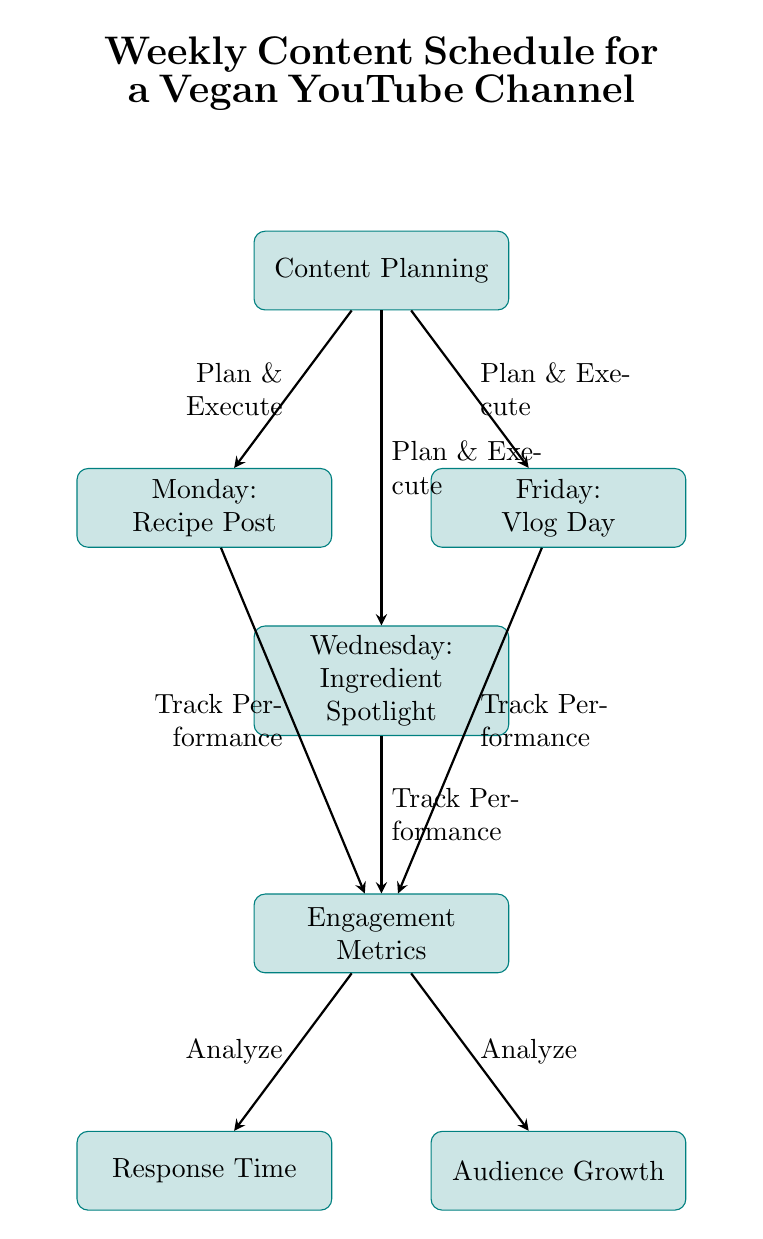What three types of content are scheduled for the week? The diagram lists the three types of content: "Recipe Post" on Monday, "Ingredient Spotlight" on Wednesday, and "Vlog Day" on Friday.
Answer: Recipe Post, Ingredient Spotlight, Vlog Day How many main activities are listed in the diagram? There are three main content activities (Recipe Post, Ingredient Spotlight, Vlog Day) along with two engagement metrics (Response Time, Audience Growth), totaling five activities.
Answer: Five Which day is associated with the "Response Time" metric? The "Response Time" metric is directly linked to the "Engagement Metrics" node, which is below "Wednesday," hence it is indirectly associated with all three content days but the question specifically asks for the placement under the metrics, so it corresponds to Wednesday.
Answer: Wednesday What is the role of the "Planning" node in the diagram? The "Planning" node is crucial as it initiates the process by detailing that all content (Monday, Wednesday, Friday) is derived from the actions "Plan & Execute." All arrows point from "Planning" to the three content types.
Answer: Plan & Execute What two metrics are analyzed after content is posted? After tracking performance from the three content types, the two engagement metrics that are analyzed are "Response Time" and "Audience Growth." They are positioned below the "Engagement Metrics" node.
Answer: Response Time, Audience Growth Which content activity comes first in the weekly schedule? The first content activity in the weekly schedule is the "Recipe Post," which is scheduled for Monday, positioning it at the top of the three content blocks in the diagram.
Answer: Recipe Post How does the diagram show the relationship between content and metrics? The arrows depict that each content type feeds into the "Engagement Metrics" node, indicating feedback on performance and engagement for all three activities, highlighting a sequential relationship of execution to evaluation.
Answer: Sequential relationship 